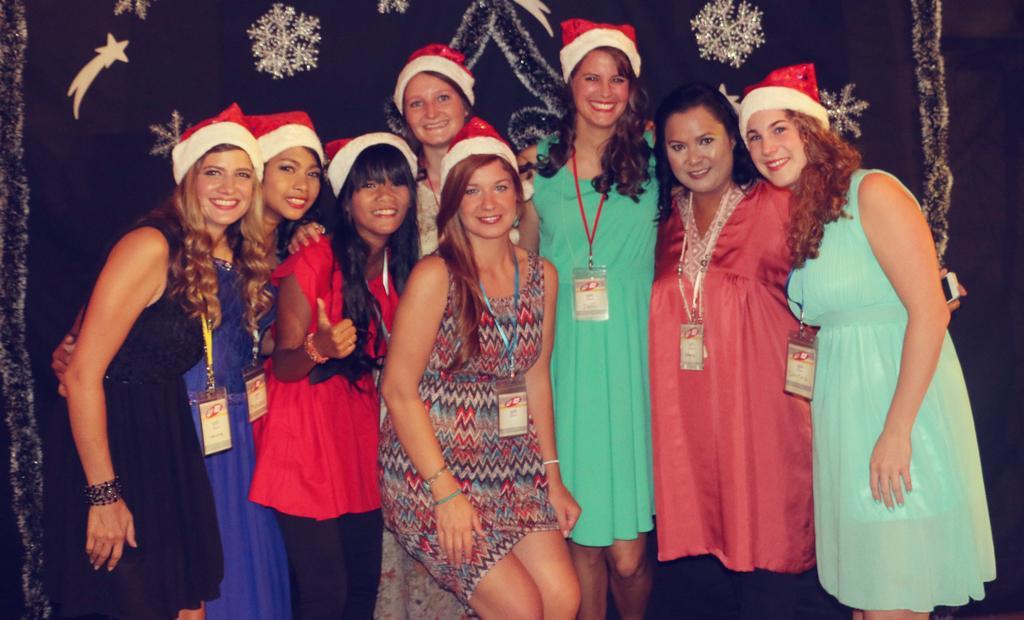How would you summarize this image in a sentence or two? In the middle of the image few women are standing and smiling. Behind them there is a curtain. 